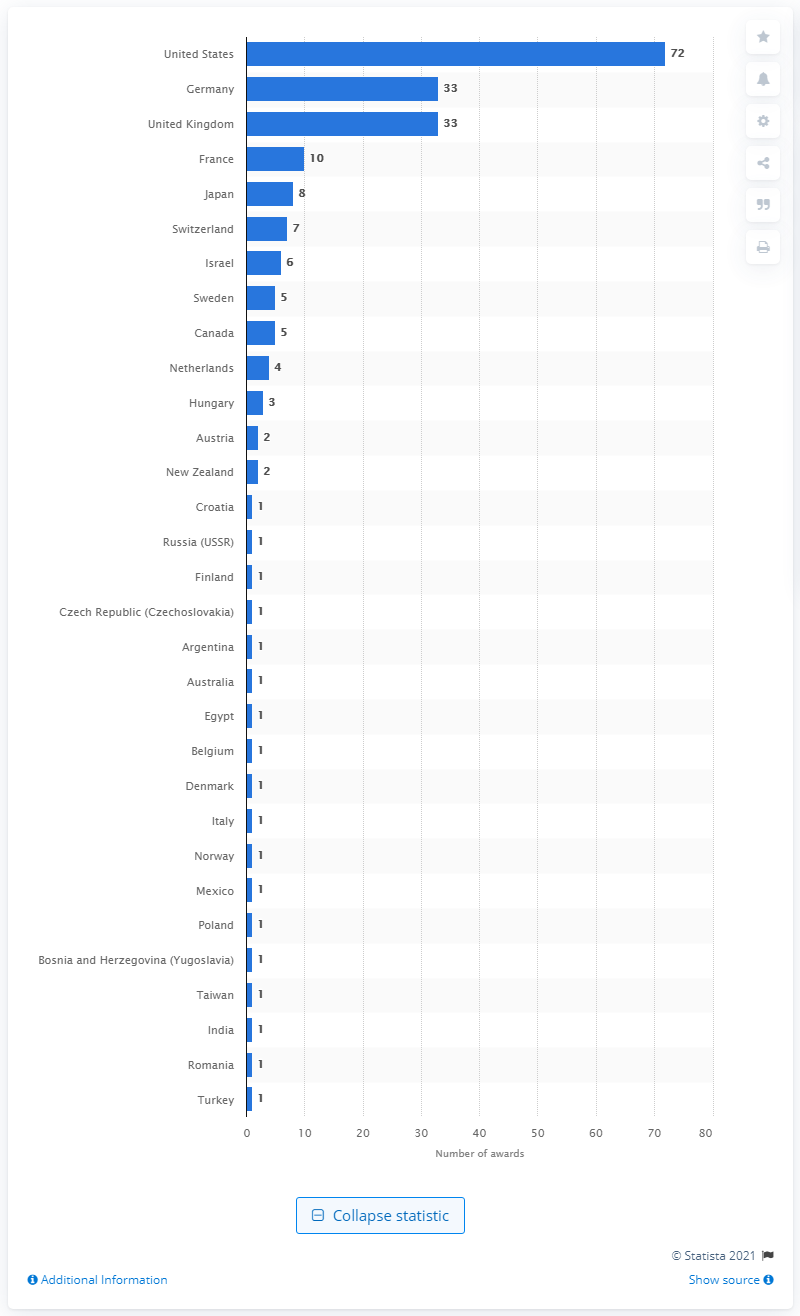Indicate a few pertinent items in this graphic. Seventy-two Nobel Prize Laureates have been awarded to individuals from the United States since 1901. A total of 33 Nobel Prize Laureates have hailed from Germany and the UK. 